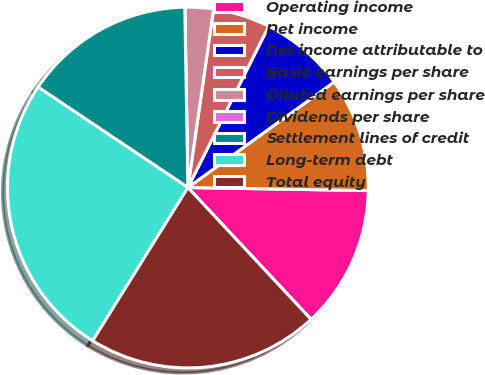Convert chart to OTSL. <chart><loc_0><loc_0><loc_500><loc_500><pie_chart><fcel>Operating income<fcel>Net income<fcel>Net income attributable to<fcel>Basic earnings per share<fcel>Diluted earnings per share<fcel>Dividends per share<fcel>Settlement lines of credit<fcel>Long-term debt<fcel>Total equity<nl><fcel>12.77%<fcel>10.22%<fcel>7.66%<fcel>5.11%<fcel>2.55%<fcel>0.0%<fcel>15.33%<fcel>25.54%<fcel>20.81%<nl></chart> 